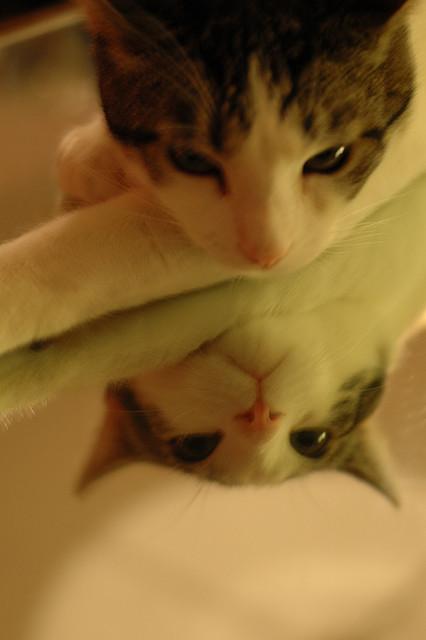What is the reflection of?
Short answer required. Cat. What colors are the cat?
Write a very short answer. White and gray. What color are the cats spots?
Quick response, please. Brown. Can the cat see its leg in the reflection?
Give a very brief answer. Yes. 